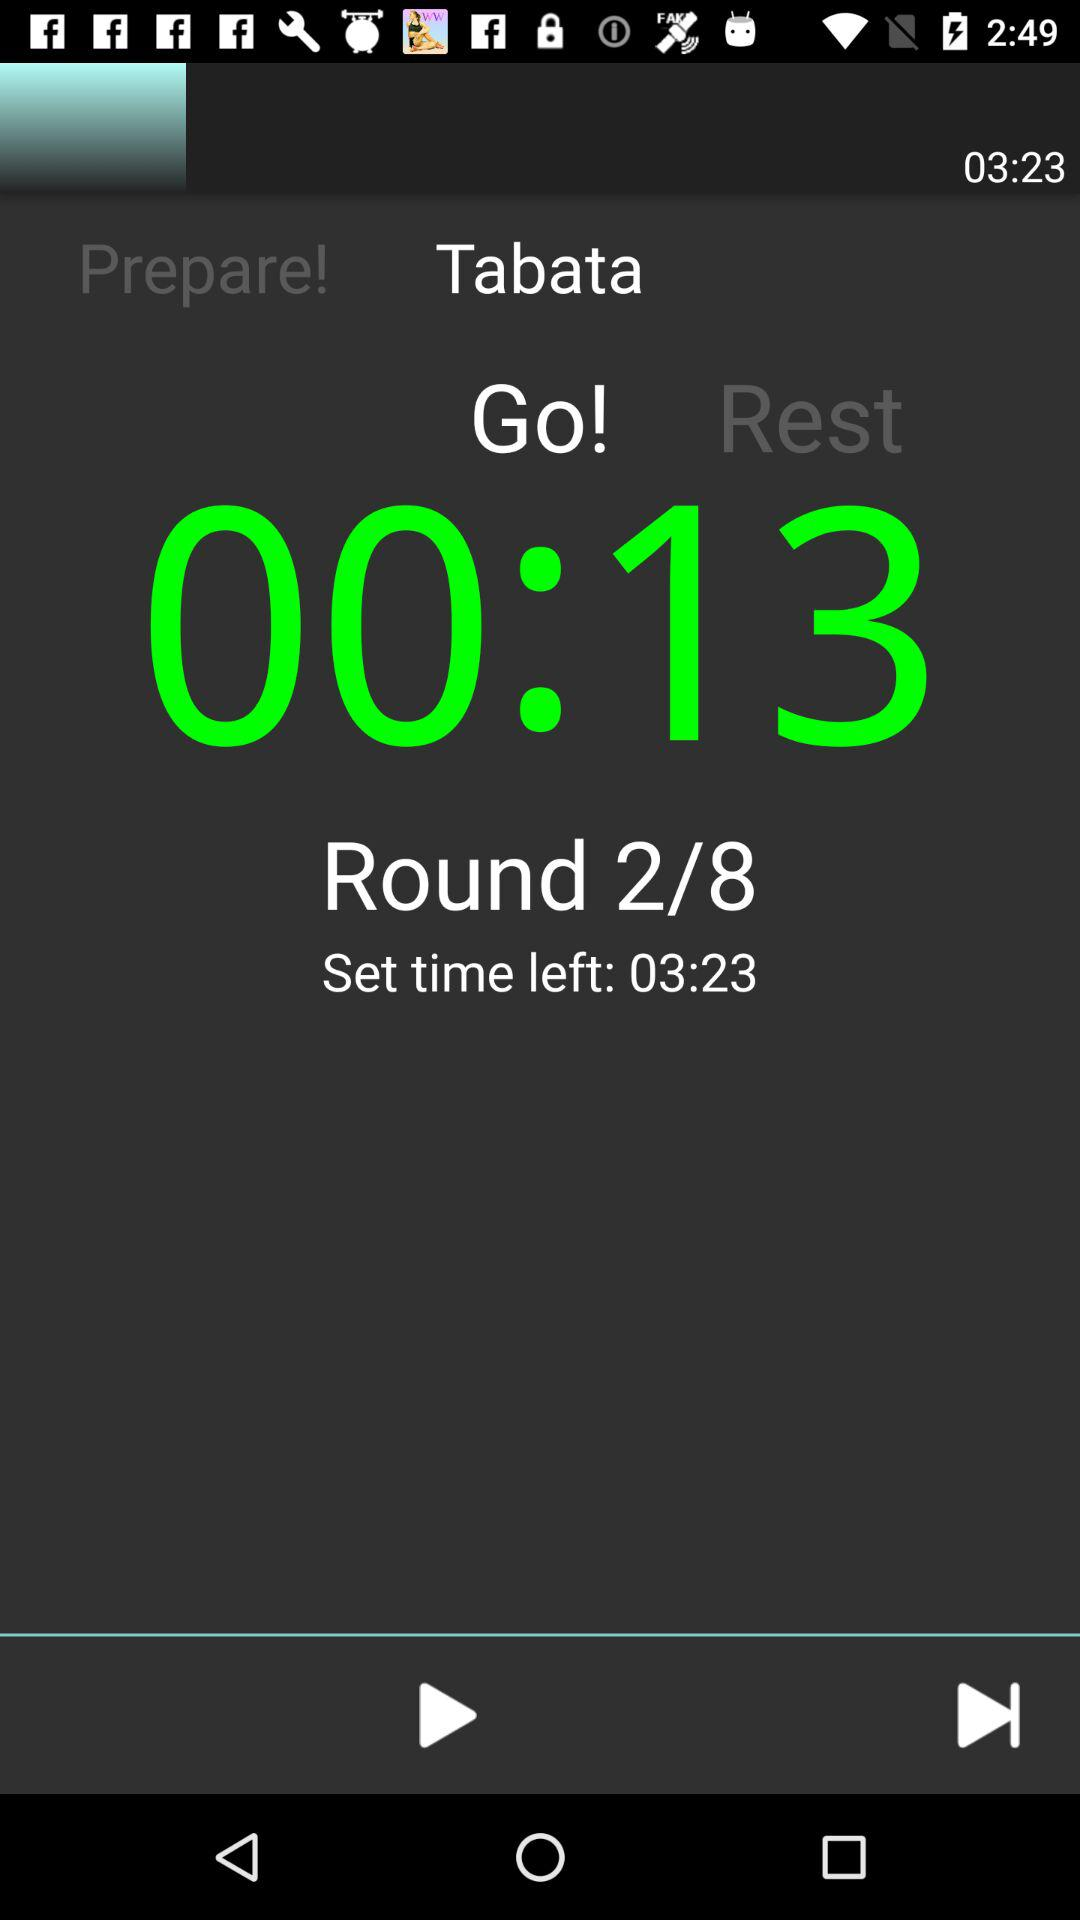How much time is remaining in the set?
Answer the question using a single word or phrase. 00:13 